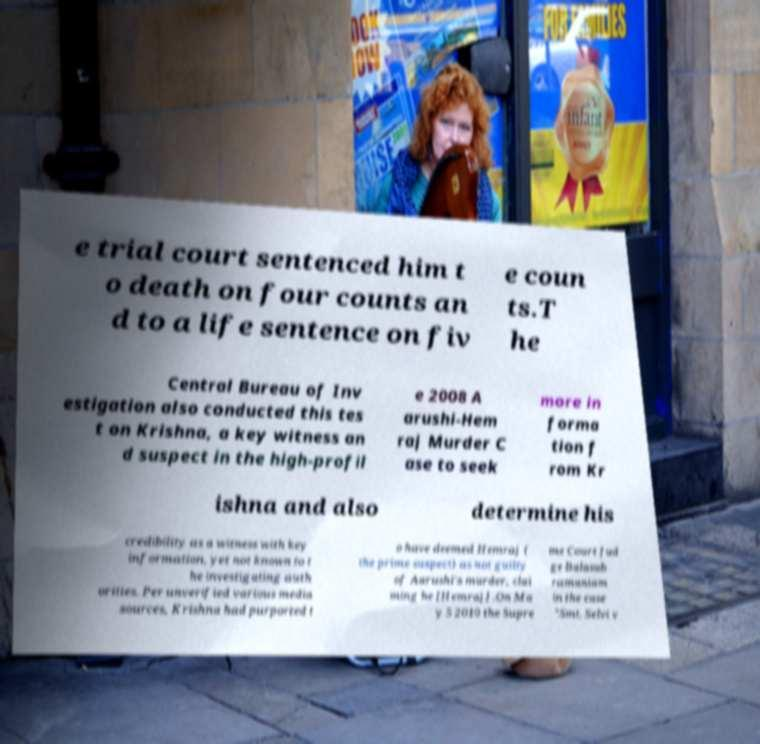Could you assist in decoding the text presented in this image and type it out clearly? e trial court sentenced him t o death on four counts an d to a life sentence on fiv e coun ts.T he Central Bureau of Inv estigation also conducted this tes t on Krishna, a key witness an d suspect in the high-profil e 2008 A arushi-Hem raj Murder C ase to seek more in forma tion f rom Kr ishna and also determine his credibility as a witness with key information, yet not known to t he investigating auth orities. Per unverified various media sources, Krishna had purported t o have deemed Hemraj ( the prime suspect) as not guilty of Aarushi's murder, clai ming he [Hemraj] .On Ma y 5 2010 the Supre me Court Jud ge Balasub ramaniam in the case "Smt. Selvi v 